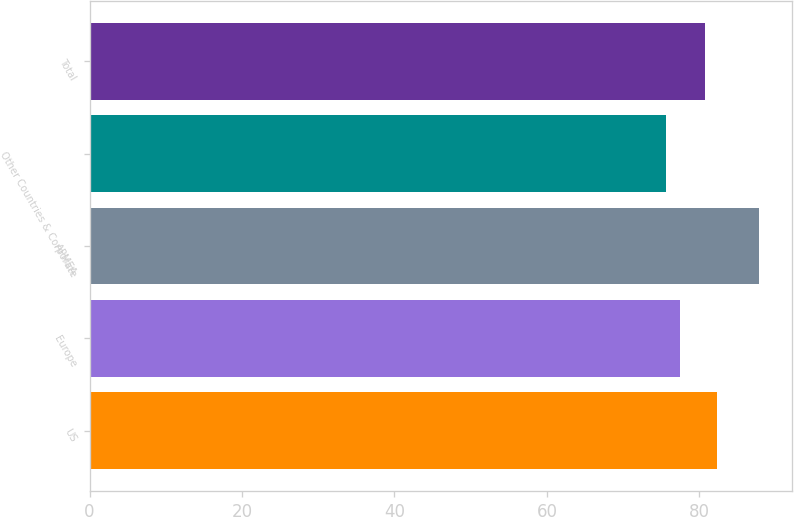Convert chart to OTSL. <chart><loc_0><loc_0><loc_500><loc_500><bar_chart><fcel>US<fcel>Europe<fcel>APMEA<fcel>Other Countries & Corporate<fcel>Total<nl><fcel>82.3<fcel>77.4<fcel>87.8<fcel>75.6<fcel>80.7<nl></chart> 